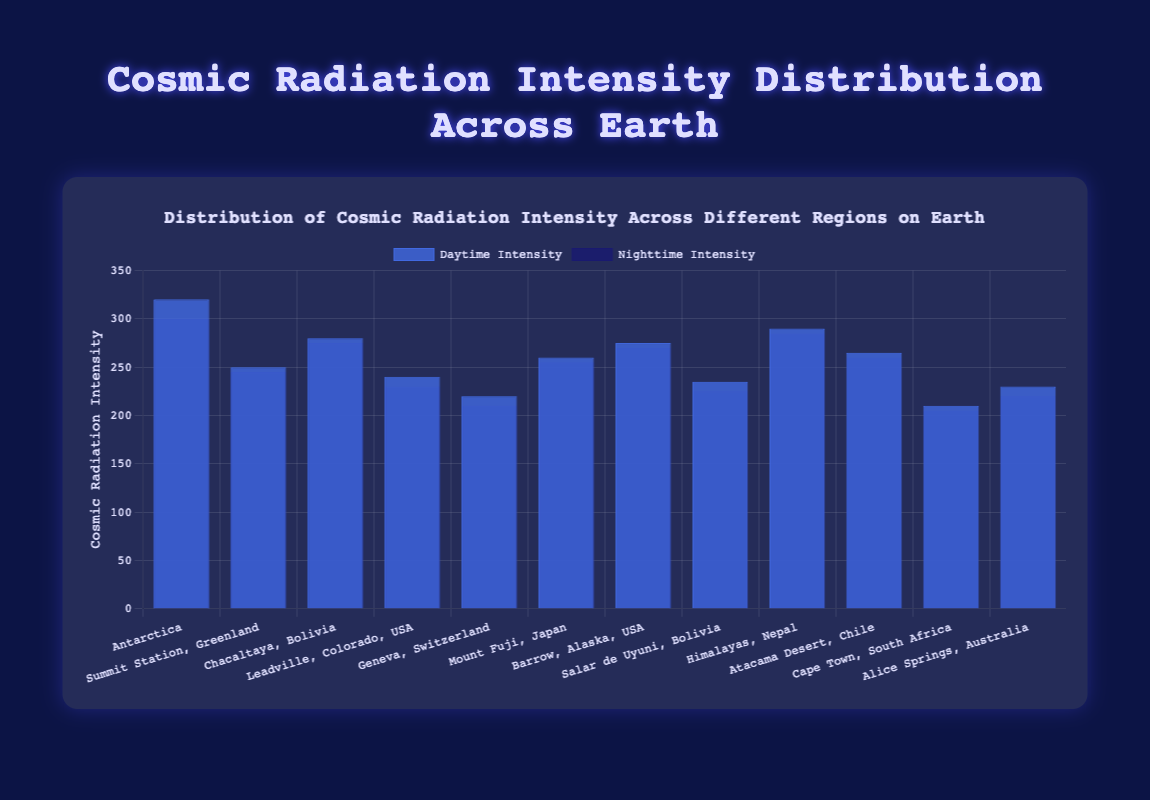What is the difference in daytime and nighttime cosmic radiation intensity at Antarctica? In the figure, the daytime intensity at Antarctica is 320, and the nighttime intensity is 300. The difference is calculated by subtracting the nighttime value from the daytime value: 320 - 300 = 20
Answer: 20 Which region has the highest cosmic radiation intensity during the daytime? To find the highest daytime intensity, look at the heights of the blue bars (representing daytime intensity) across all regions. The tallest blue bar corresponds to Antarctica with a value of 320.
Answer: Antarctica Compare the daytime cosmic radiation intensity between Mount Fuji, Japan and Atacama Desert, Chile. Which region experiences higher intensity? Compare the height of the blue bars for Mount Fuji (260) and Atacama Desert (265). The Atacama Desert has a higher daytime intensity as the blue bar is slightly taller.
Answer: Atacama Desert, Chile Which region shows the smallest difference between daytime and nighttime cosmic radiation intensity? To find the smallest difference, subtract the nighttime value from the daytime value for each region: 
- Summit Station, Greenland: 250 - 245 = 5 
- Chacaltaya, Bolivia: 280 - 275 = 5 
- Leadville, Colorado, USA: 240 - 230 = 10 
- Geneva, Switzerland: 220 - 210 = 10 
- Mount Fuji, Japan: 260 - 255 = 5 
- Barrow, Alaska, USA: 275 - 270 = 5 
- Salar de Uyuni, Bolivia: 235 - 225 = 10 
- Himalayas, Nepal: 290 - 285 = 5 
- Atacama Desert, Chile: 265 - 260 = 5 
- Cape Town, South Africa: 210 - 205 = 5 
- Alice Springs, Australia: 230 - 220 = 10 
The smallest difference, 5, occurs in Summit Station, Greenland; Chacaltaya, Bolivia; Mount Fuji, Japan; Barrow, Alaska, USA; Himalayas, Nepal; Atacama Desert, Chile; Cape Town, South Africa.
Answer: Summit Station, Greenland; Chacaltaya, Bolivia; Mount Fuji, Japan; Barrow, Alaska, USA; Himalayas, Nepal; Atacama Desert, Chile; Cape Town, South Africa What is the average nighttime cosmic radiation intensity across all regions? To find the average, sum the nighttime intensities of all regions and divide by the number of regions:
(300 + 245 + 275 + 230 + 210 + 255 + 270 + 225 + 285 + 260 + 205 + 220) / 12 = 3280 / 12 = 273.33
Answer: 273.33 Which region exhibits the second highest nighttime cosmic radiation intensity? Observe and compare the heights of the dark blue bars (representing nighttime intensity). The highest nighttime intensity is at Antarctica (300), and the second highest is at Himalayas, Nepal (285).
Answer: Himalayas, Nepal Is there any region where the nighttime cosmic radiation intensity is greater than the daytime intensity? By comparing the heights of the blue and dark blue bars in each region, it’s noticeable that in all regions, the daytime intensities (blue bars) are higher than the nighttime intensities (dark blue bars). Therefore, there's no such region.
Answer: No Compare the cosmic radiation intensities between the regions in Bolivia. Which region has a higher average intensity? There are two regions in Bolivia: Chacaltaya and Salar de Uyuni. Calculate the average intensity for each region by summing both daytime and nighttime values and dividing by 2:
- Chacaltaya: (280 + 275) / 2 = 277.5 
- Salar de Uyuni: (235 + 225) / 2 = 230 
Chacaltaya has a higher average intensity.
Answer: Chacaltaya Which region exhibits the lowest daytime cosmic radiation intensity? Look for the smallest blue bar height, which corresponds to Cape Town, South Africa with a value of 210.
Answer: Cape Town, South Africa 